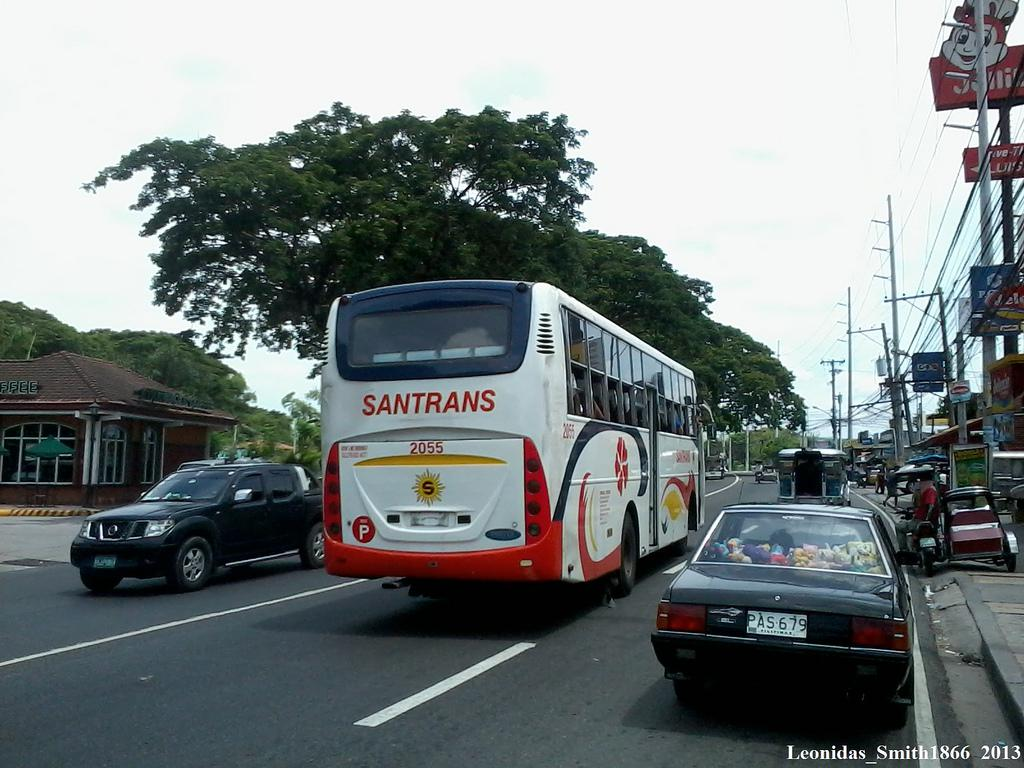Question: where are the power lines and tall business signs?
Choices:
A. On the left.
B. In the background.
C. On the right.
D. On the hill..
Answer with the letter. Answer: C Question: what direction is the bus traveling in?
Choices:
A. North.
B. South.
C. Away from the viewer.
D. East.
Answer with the letter. Answer: C Question: what is piled in the rear window of the car parked on the right?
Choices:
A. Clothes.
B. Hats.
C. Stuffed animals.
D. Toys.
Answer with the letter. Answer: C Question: what three paint colors, other than white, can be seen on the back of the bus?
Choices:
A. Green, orange and yellow.
B. Red, yellow, and blue.
C. Black, brown and green.
D. Purple, tan and green.
Answer with the letter. Answer: B Question: how do they mark the bus?
Choices:
A. With paint.
B. With the company name.
C. Numbered 2055.
D. In an auto body shop.
Answer with the letter. Answer: C Question: where are the white markings?
Choices:
A. On the street.
B. On his lapel.
C. On the field of play.
D. On the van.
Answer with the letter. Answer: A Question: how many black cars are there?
Choices:
A. Two.
B. Three.
C. Four.
D. Five.
Answer with the letter. Answer: A Question: where is white, yellow, blue and red?
Choices:
A. In her closet.
B. On the flag of that country.
C. On the bus.
D. On the workout clothes.
Answer with the letter. Answer: C Question: what is white?
Choices:
A. Bus.
B. A tiger.
C. Hair.
D. Sneakers.
Answer with the letter. Answer: A Question: what kind of scene is it?
Choices:
A. Ball game.
B. Outdoor.
C. Tennis game.
D. A charity auction.
Answer with the letter. Answer: B Question: what is white?
Choices:
A. A wedding dress.
B. A cat.
C. Lines on the street.
D. Snow.
Answer with the letter. Answer: C Question: what if facing camera?
Choices:
A. The side of a building.
B. A train.
C. A model.
D. Back of a car.
Answer with the letter. Answer: D Question: what is small and black?
Choices:
A. A phone.
B. A phone book.
C. A wallet.
D. Car.
Answer with the letter. Answer: D Question: what is black?
Choices:
A. Truck passing the coffee shop.
B. The woman's dress.
C. The bird in the sky.
D. The dog's fur.
Answer with the letter. Answer: A 